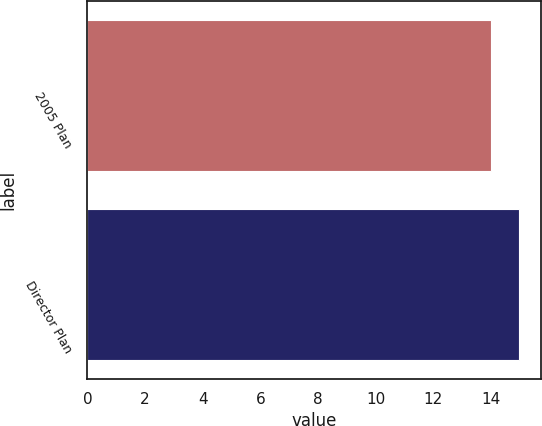Convert chart to OTSL. <chart><loc_0><loc_0><loc_500><loc_500><bar_chart><fcel>2005 Plan<fcel>Director Plan<nl><fcel>14<fcel>15<nl></chart> 